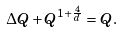Convert formula to latex. <formula><loc_0><loc_0><loc_500><loc_500>\Delta Q + Q ^ { 1 + \frac { 4 } { d } } = Q .</formula> 